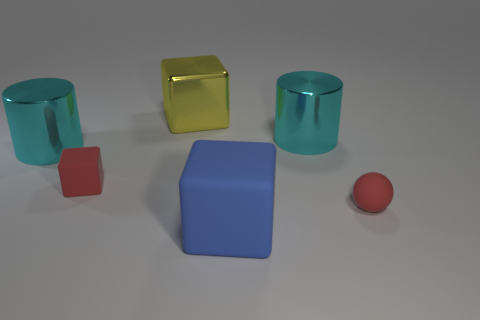Add 3 cyan objects. How many objects exist? 9 Subtract all cylinders. How many objects are left? 4 Subtract 0 cyan cubes. How many objects are left? 6 Subtract all large shiny balls. Subtract all yellow metallic objects. How many objects are left? 5 Add 1 small cubes. How many small cubes are left? 2 Add 5 small red rubber things. How many small red rubber things exist? 7 